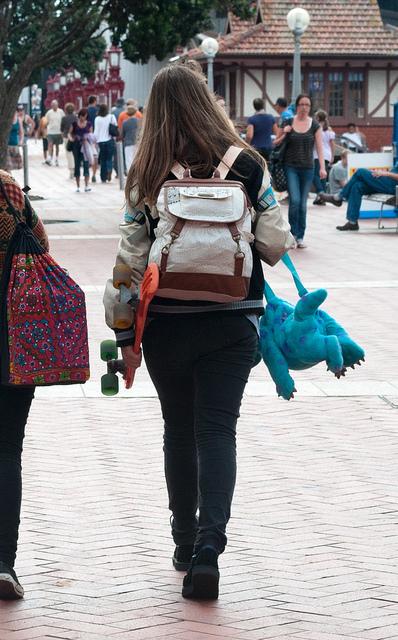Is the woman carrying more than one item?
Quick response, please. Yes. What does the woman have on her back?
Keep it brief. Backpack. Is the woman carrying a childs object?
Write a very short answer. Yes. 